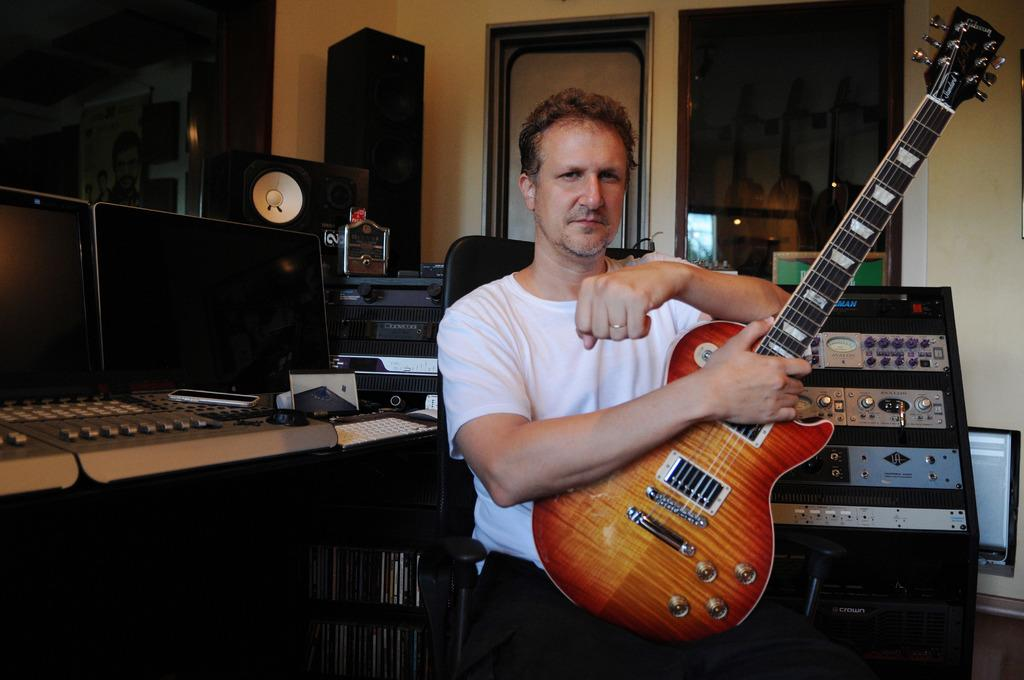What is the man in the image holding? The man is holding a guitar. What can be seen in the background of the image? There are screens, speakers, a door, a machine, and a window in the background of the image. What might the man be doing with the guitar? The man might be playing or preparing to play the guitar. What type of pollution can be seen in the image? There is no pollution visible in the image. How does the man's wealth affect the image? The image does not provide any information about the man's wealth, so it cannot be determined how it might affect the image. 